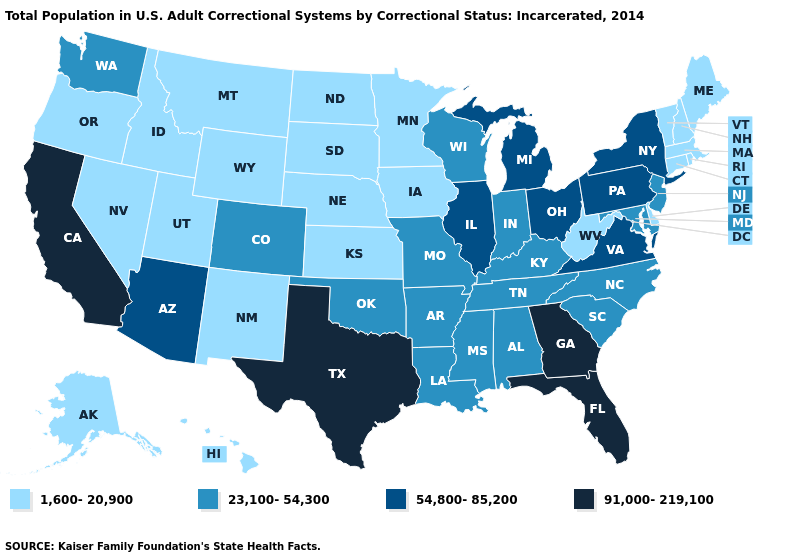Name the states that have a value in the range 91,000-219,100?
Short answer required. California, Florida, Georgia, Texas. Name the states that have a value in the range 23,100-54,300?
Answer briefly. Alabama, Arkansas, Colorado, Indiana, Kentucky, Louisiana, Maryland, Mississippi, Missouri, New Jersey, North Carolina, Oklahoma, South Carolina, Tennessee, Washington, Wisconsin. Among the states that border Virginia , does West Virginia have the lowest value?
Short answer required. Yes. Does the first symbol in the legend represent the smallest category?
Concise answer only. Yes. Does Florida have the highest value in the USA?
Short answer required. Yes. What is the value of Nevada?
Give a very brief answer. 1,600-20,900. Does the map have missing data?
Give a very brief answer. No. Does Rhode Island have a lower value than Montana?
Be succinct. No. Does Colorado have the highest value in the West?
Be succinct. No. What is the value of New Jersey?
Keep it brief. 23,100-54,300. Does the map have missing data?
Keep it brief. No. Name the states that have a value in the range 91,000-219,100?
Answer briefly. California, Florida, Georgia, Texas. Among the states that border Virginia , which have the lowest value?
Concise answer only. West Virginia. Does the map have missing data?
Give a very brief answer. No. What is the value of Hawaii?
Write a very short answer. 1,600-20,900. 